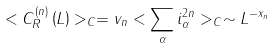Convert formula to latex. <formula><loc_0><loc_0><loc_500><loc_500>< C _ { R } ^ { \left ( n \right ) } \left ( L \right ) > _ { C } = v _ { n } < \sum _ { \alpha } i _ { \alpha } ^ { 2 n } > _ { C } \sim L ^ { - x _ { n } }</formula> 